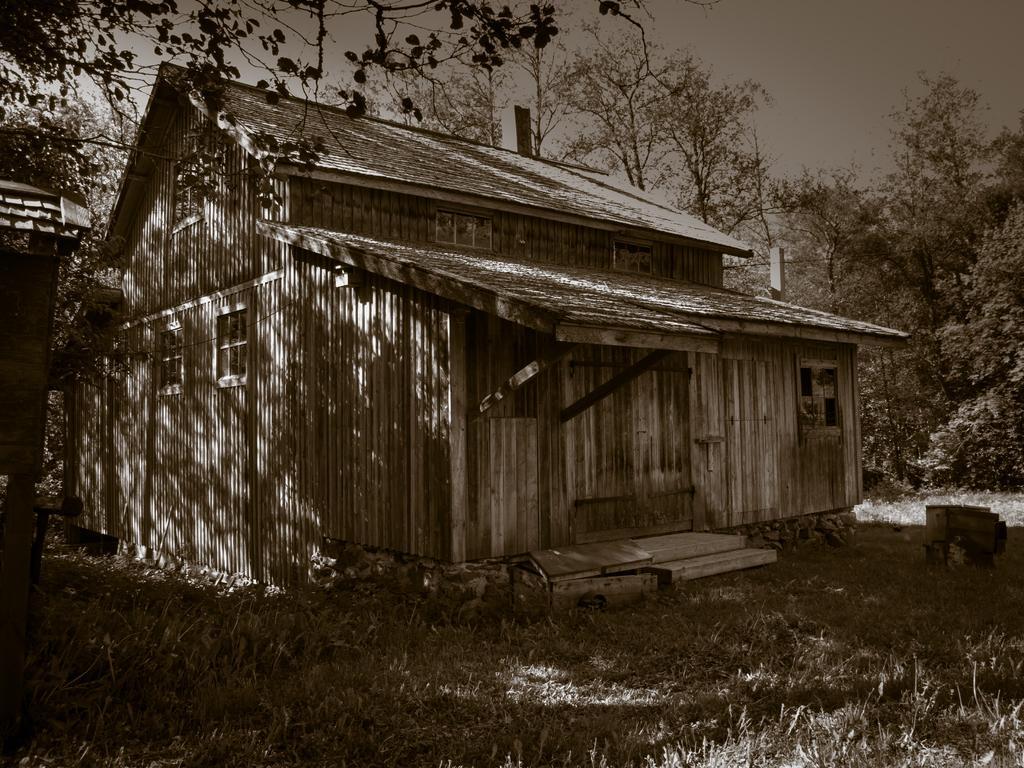In one or two sentences, can you explain what this image depicts? In this image I can see a house, trees, the grass and the sky. This picture is black and white in color. 